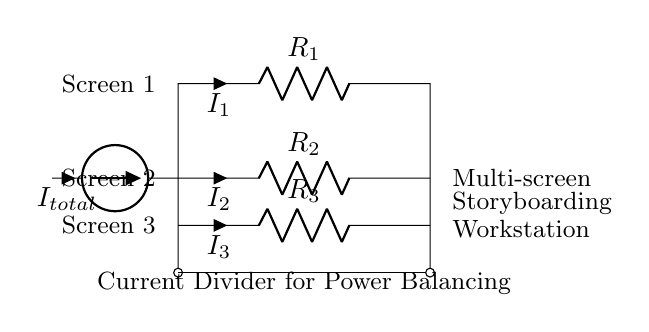What is the total current entering the circuit? The total current entering the circuit is denoted as I total, which is the current source connected to the input of the circuit.
Answer: I total What are the resistances in the circuit? The circuit contains three resistors: R 1, R 2, and R 3, which are all indicated in the diagram.
Answer: R 1, R 2, R 3 Which screen has the highest current? The current flowing through each resistor corresponds to the screens; the highest value corresponds to the screen with the lowest resistance. Without specific resistance values, we can assume based on positions that screen 1 likely has the highest current since it is positioned where I 1 flows through R 1.
Answer: Screen 1 How does the current divide among the screens? In a current divider, the total current splits inversely proportional to the resistances; lower resistance receives a higher share of the current. Thus, calculations based on the resistance values for R 1, R 2, and R 3 would be necessary for exact currents.
Answer: Inversely proportional What is the function of this current divider in the circuit? The function of this current divider is to balance power consumption across multiple screens by distributing the available current according to the resistances of R 1, R 2, and R 3.
Answer: Balance power consumption What is the configuration type of this current divider? This circuit is a parallel configuration of resistors, which is typical of current dividers; the resistors are connected side by side to the same voltage source.
Answer: Parallel configuration 